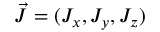Convert formula to latex. <formula><loc_0><loc_0><loc_500><loc_500>\vec { J } = ( J _ { x } , J _ { y } , J _ { z } )</formula> 